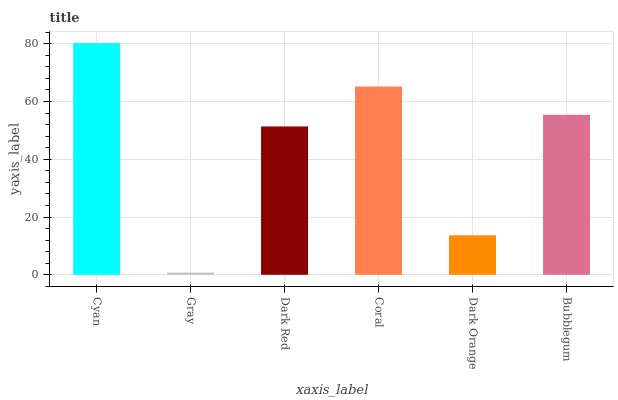Is Dark Red the minimum?
Answer yes or no. No. Is Dark Red the maximum?
Answer yes or no. No. Is Dark Red greater than Gray?
Answer yes or no. Yes. Is Gray less than Dark Red?
Answer yes or no. Yes. Is Gray greater than Dark Red?
Answer yes or no. No. Is Dark Red less than Gray?
Answer yes or no. No. Is Bubblegum the high median?
Answer yes or no. Yes. Is Dark Red the low median?
Answer yes or no. Yes. Is Dark Orange the high median?
Answer yes or no. No. Is Dark Orange the low median?
Answer yes or no. No. 